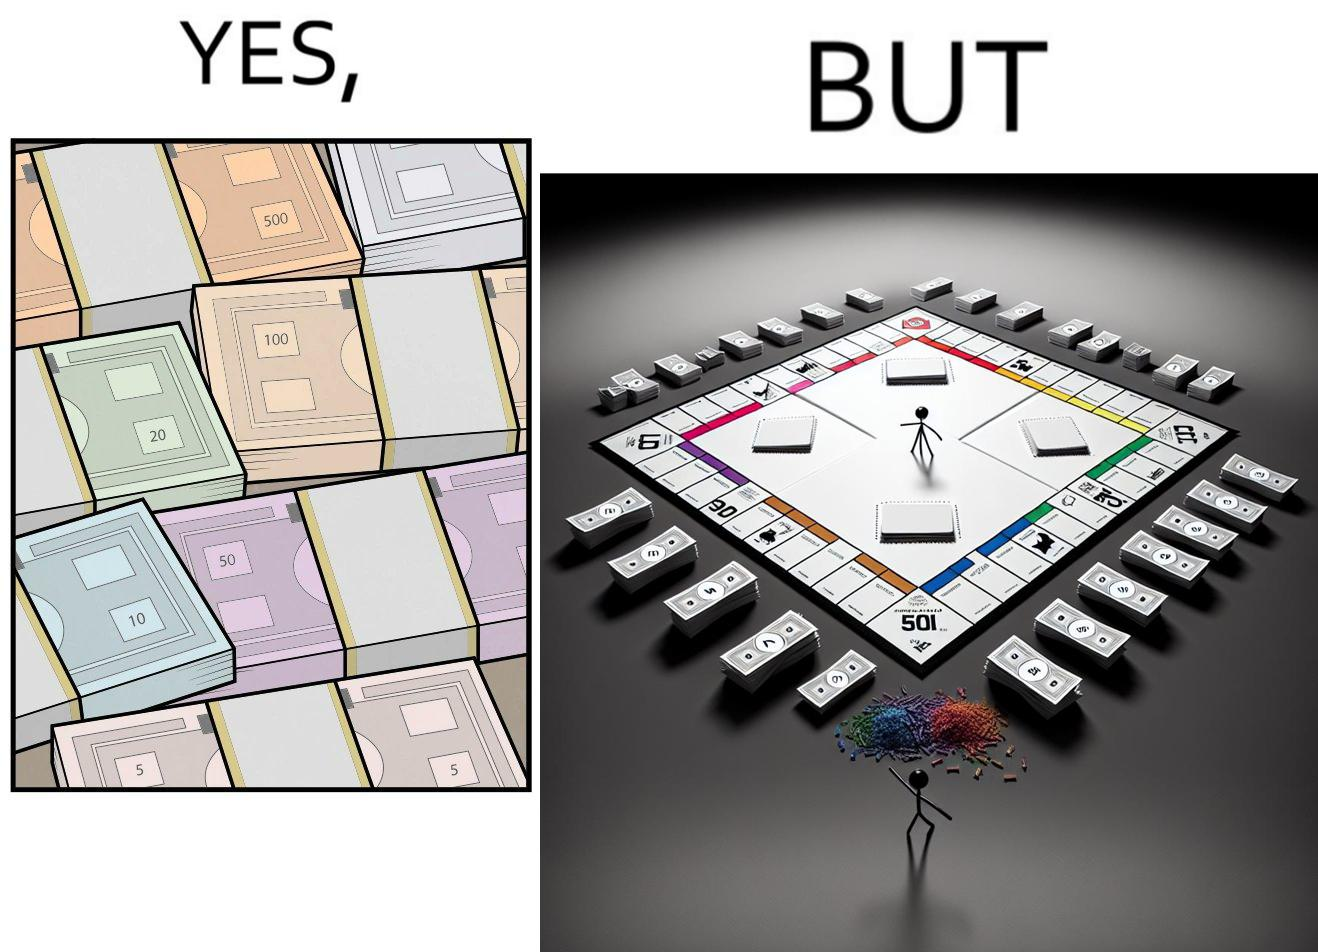Provide a description of this image. The image is ironic, because there are many different color currency notes' bundles but they are just as a currency in the game of monopoly and they have no real value 